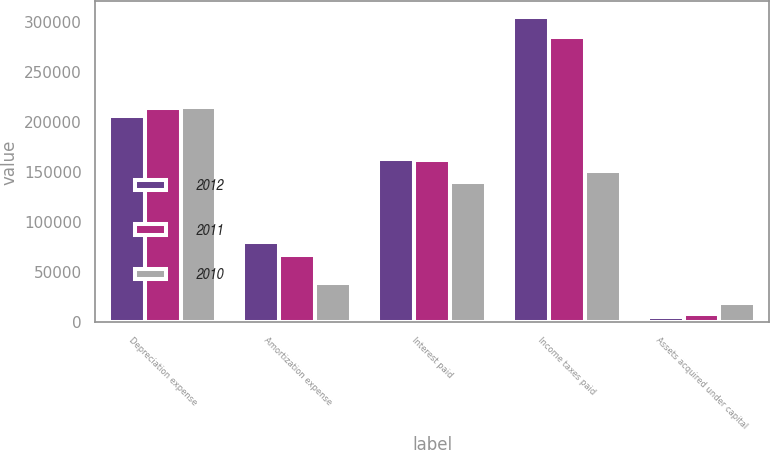<chart> <loc_0><loc_0><loc_500><loc_500><stacked_bar_chart><ecel><fcel>Depreciation expense<fcel>Amortization expense<fcel>Interest paid<fcel>Income taxes paid<fcel>Assets acquired under capital<nl><fcel>2012<fcel>206299<fcel>80297<fcel>163121<fcel>305428<fcel>5580<nl><fcel>2011<fcel>214070<fcel>67032<fcel>161820<fcel>285269<fcel>8369<nl><fcel>2010<fcel>214743<fcel>39221<fcel>139802<fcel>150811<fcel>18818<nl></chart> 